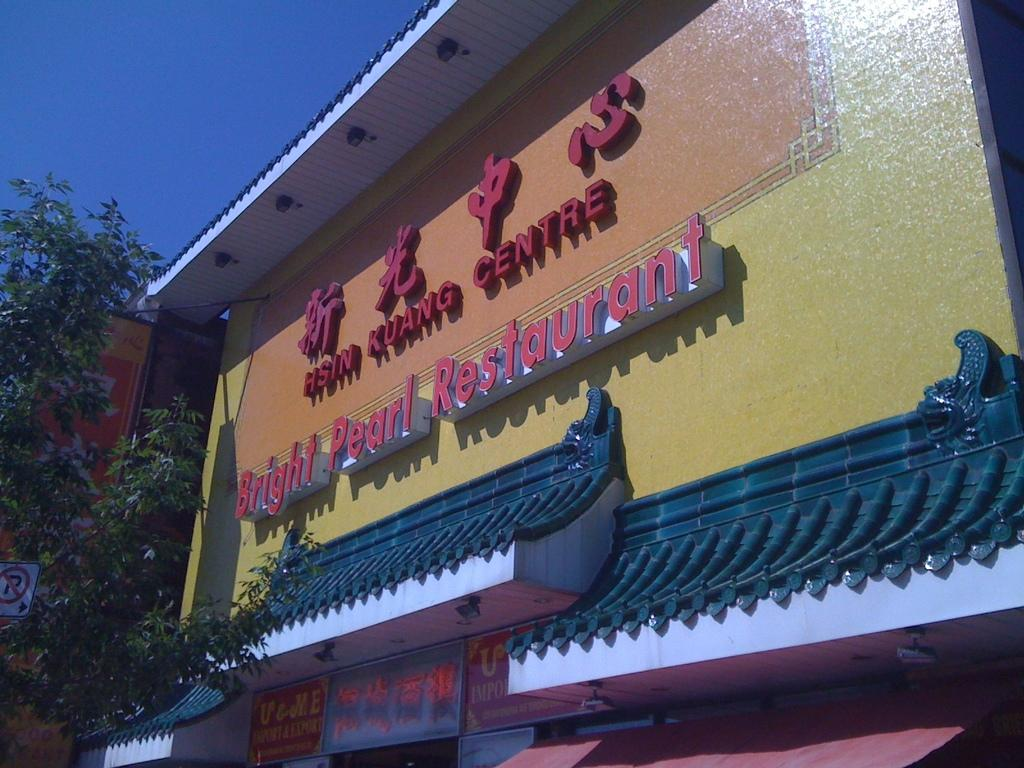<image>
Relay a brief, clear account of the picture shown. The Bright Pearl Restaurant features pagoda-style awnings over the door. 